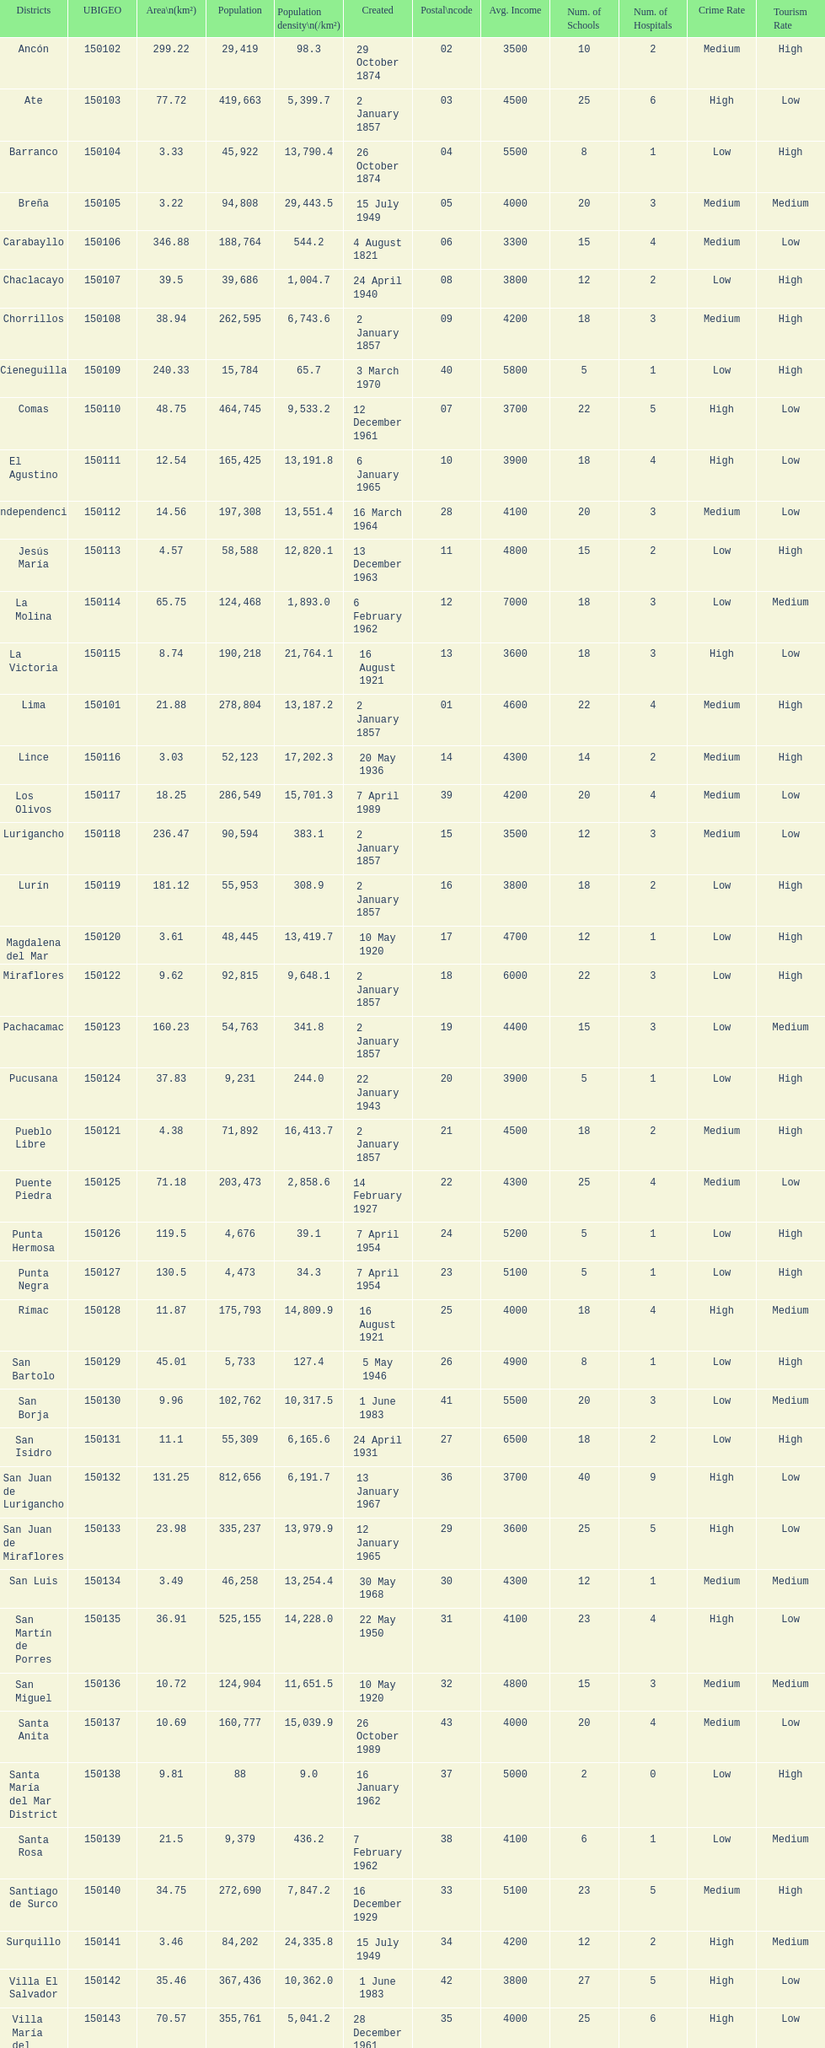What district has the least amount of population? Santa María del Mar District. 